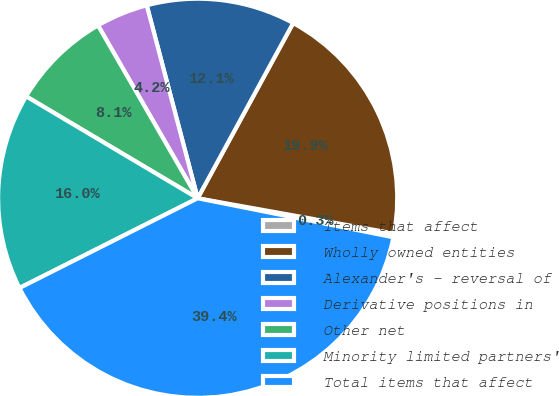Convert chart. <chart><loc_0><loc_0><loc_500><loc_500><pie_chart><fcel>Items that affect<fcel>Wholly owned entities<fcel>Alexander's - reversal of<fcel>Derivative positions in<fcel>Other net<fcel>Minority limited partners'<fcel>Total items that affect<nl><fcel>0.31%<fcel>19.88%<fcel>12.05%<fcel>4.22%<fcel>8.14%<fcel>15.96%<fcel>39.44%<nl></chart> 